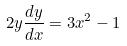<formula> <loc_0><loc_0><loc_500><loc_500>2 y \frac { d y } { d x } = 3 x ^ { 2 } - 1</formula> 